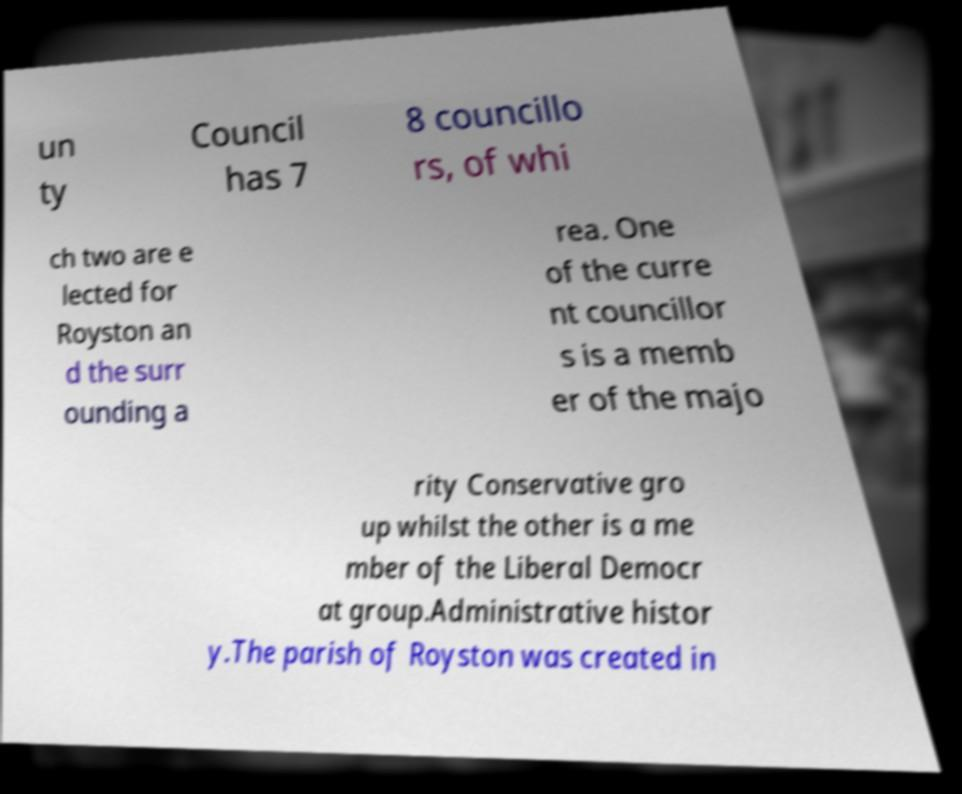Can you read and provide the text displayed in the image?This photo seems to have some interesting text. Can you extract and type it out for me? un ty Council has 7 8 councillo rs, of whi ch two are e lected for Royston an d the surr ounding a rea. One of the curre nt councillor s is a memb er of the majo rity Conservative gro up whilst the other is a me mber of the Liberal Democr at group.Administrative histor y.The parish of Royston was created in 